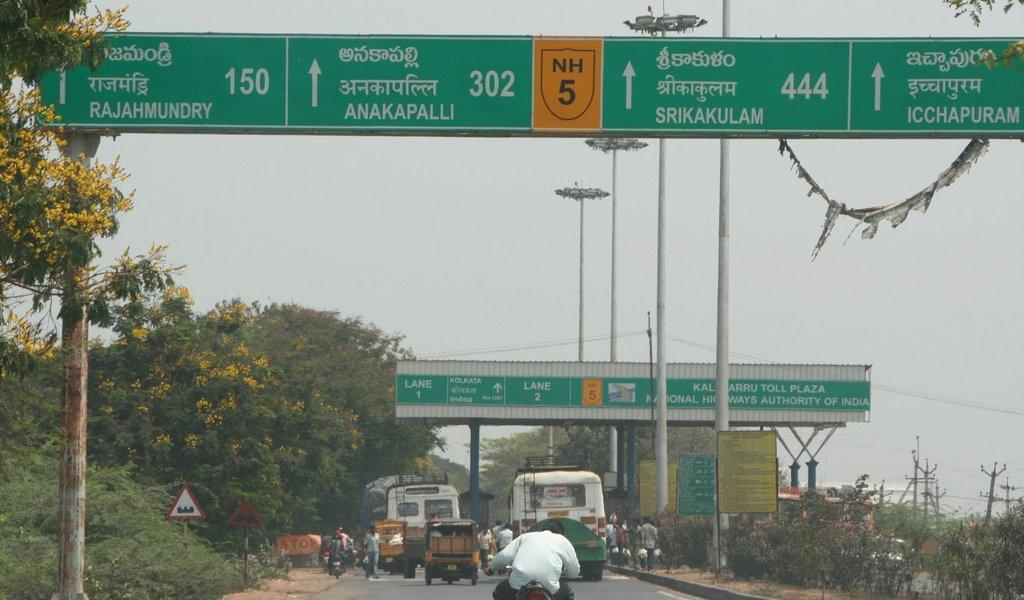<image>
Provide a brief description of the given image. The toll plaza on a highway shows Lane 1 and Lane 2. 